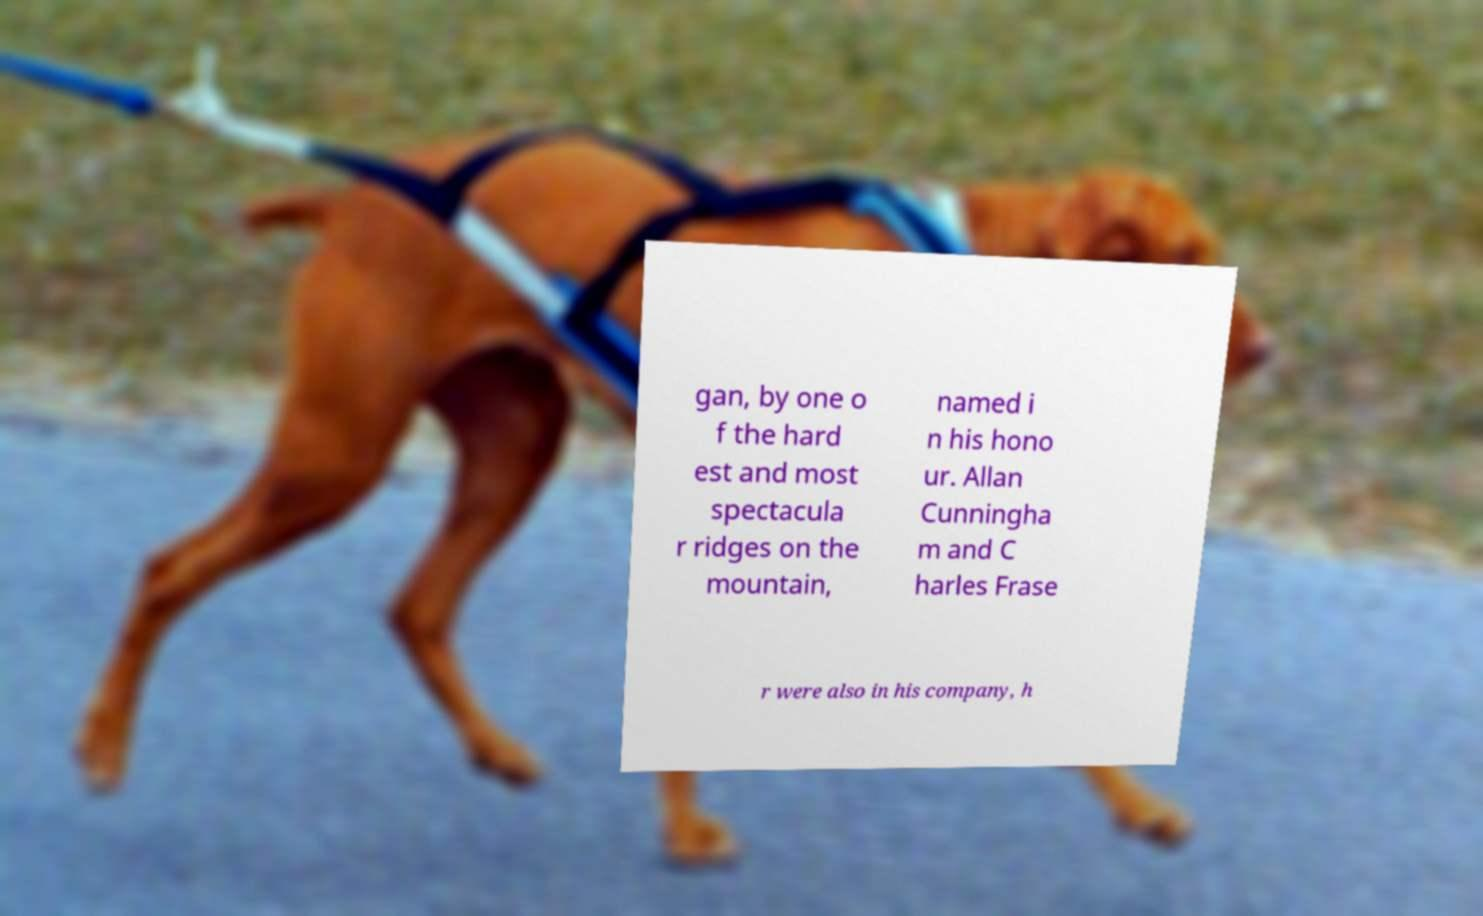Could you assist in decoding the text presented in this image and type it out clearly? gan, by one o f the hard est and most spectacula r ridges on the mountain, named i n his hono ur. Allan Cunningha m and C harles Frase r were also in his company, h 